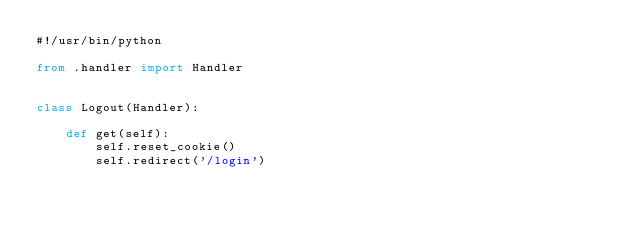<code> <loc_0><loc_0><loc_500><loc_500><_Python_>#!/usr/bin/python

from .handler import Handler


class Logout(Handler):

    def get(self):
        self.reset_cookie()
        self.redirect('/login')
</code> 